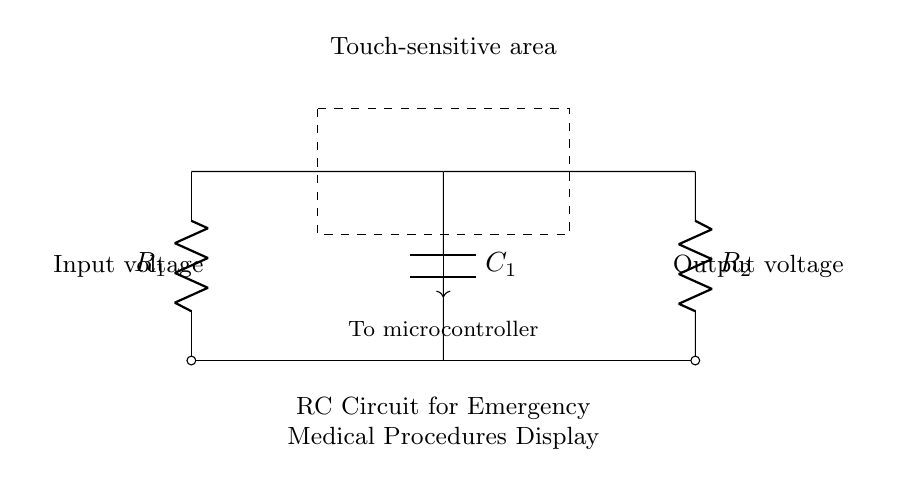What components are in this circuit? The circuit contains two resistors (R1 and R2) and one capacitor (C1).
Answer: R1, R2, C1 What does the dashed rectangle represent? The dashed rectangle indicates the touch-sensitive area where a user can interact with the circuit.
Answer: Touch-sensitive area What is the purpose of the microcontroller in this circuit? The microcontroller receives the output voltage from the circuit to process the touch input and trigger actions accordingly.
Answer: To process touch input How many resistors are in the circuit? There are two resistors, R1 and R2, connected to the circuit.
Answer: Two What happens if C1 is charged? If C1 is charged, it can affect the timing and response of the circuit by delaying the voltage change when touched.
Answer: Timing delay How would changing R1's value affect the circuit? Changing R1’s value alters the charging time of C1, affecting the responsiveness of the touch-sensitive area.
Answer: Alters responsiveness What type of circuit is this? This circuit is classified as a resistor-capacitor (RC) circuit, used for timing applications.
Answer: Resistor-capacitor 